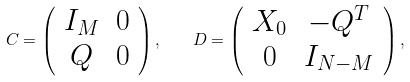Convert formula to latex. <formula><loc_0><loc_0><loc_500><loc_500>C = \left ( \begin{array} { c c } I _ { M } & 0 \\ Q & 0 \end{array} \right ) , \quad D = \left ( \begin{array} { c c } X _ { 0 } & - Q ^ { T } \\ 0 & I _ { N - M } \end{array} \right ) ,</formula> 